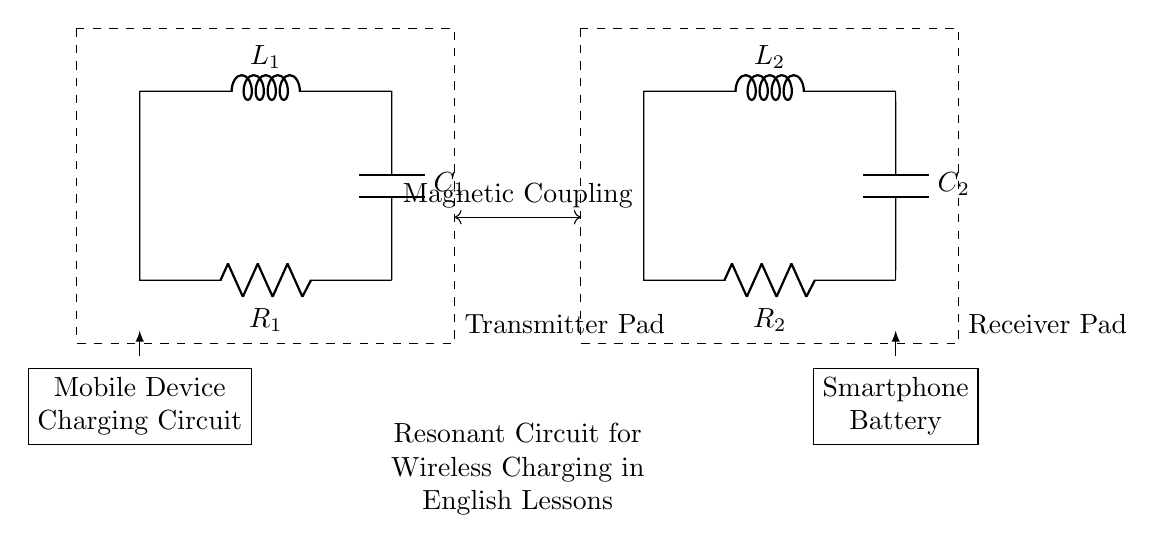What components are in the transmitter pad? The transmitter pad includes an inductor labeled L1, a capacitor labeled C1, and a resistor labeled R1. Each of these components is critical for energy transfer in the resonant circuit.
Answer: Inductor L1, Capacitor C1, Resistor R1 What is the function of the inductor in the circuit? Inductors in a resonant circuit store energy in a magnetic field when current flows through them, creating a magnetic coupling effect that allows for the transfer of energy between the transmitter and receiver pads.
Answer: Energy storage Which components are used in the receiver pad? The receiver pad consists of an inductor labeled L2, a capacitor labeled C2, and a resistor labeled R2, facilitating energy reception from the transmitter pad.
Answer: Inductor L2, Capacitor C2, Resistor R2 What is the main configuration type of this circuit? The circuit is a resonant circuit, which is characterized by the presence of inductors and capacitors that create resonance at a specific frequency, optimized for wireless power transfer.
Answer: Resonant circuit How does the magnetic coupling affect the charging process? Magnetic coupling increases efficiency in energy transfer by utilizing the magnetic fields created by the inductors L1 and L2. This allows power to wirelessly transfer from the transmitter to the receiver pads, minimizing energy loss.
Answer: Increases efficiency At which point is the mobile device connected? The mobile device is connected to the mobile device charging circuit shown at the left side of the transmitter pad, where the load of the charging process is represented.
Answer: Left side of the transmitter pad What does the dashed rectangle represent? The dashed rectangles outline the transmitter and receiver pads highlighting their functional separation while visually connecting them through magnetic coupling in the wireless charging system.
Answer: Transmitter and receiver pads 